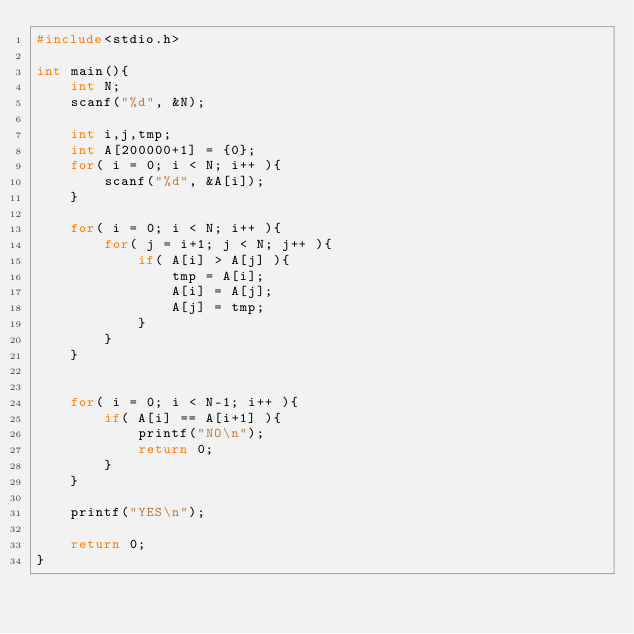Convert code to text. <code><loc_0><loc_0><loc_500><loc_500><_C_>#include<stdio.h>

int main(){
    int N;
    scanf("%d", &N);

    int i,j,tmp;
    int A[200000+1] = {0};
    for( i = 0; i < N; i++ ){
        scanf("%d", &A[i]);
    }

    for( i = 0; i < N; i++ ){
        for( j = i+1; j < N; j++ ){
            if( A[i] > A[j] ){
                tmp = A[i];
                A[i] = A[j];
                A[j] = tmp;
            }
        }
    }

    
    for( i = 0; i < N-1; i++ ){
        if( A[i] == A[i+1] ){
            printf("NO\n");
            return 0;
        }
    }

    printf("YES\n");

    return 0;
}



</code> 